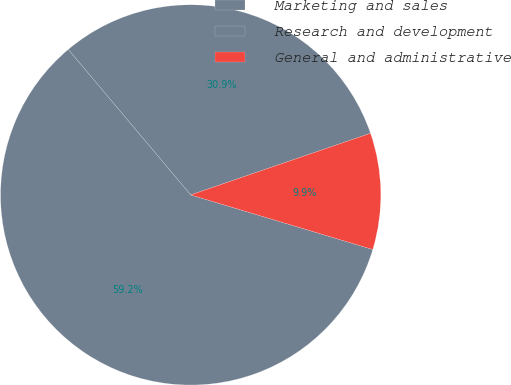<chart> <loc_0><loc_0><loc_500><loc_500><pie_chart><fcel>Marketing and sales<fcel>Research and development<fcel>General and administrative<nl><fcel>30.88%<fcel>59.24%<fcel>9.89%<nl></chart> 